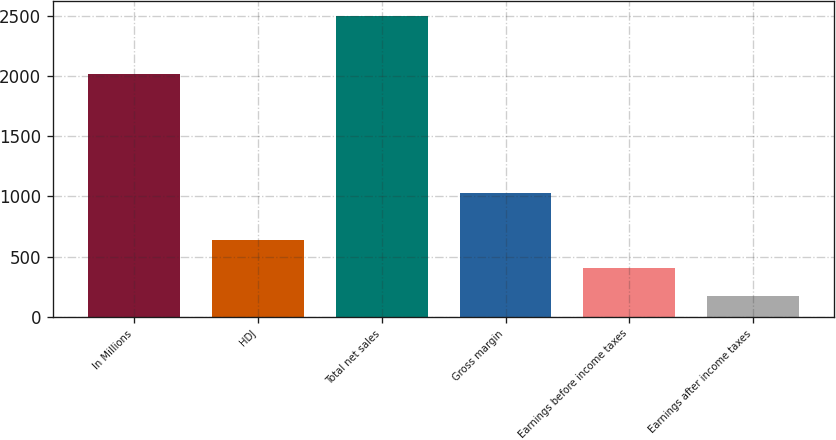Convert chart to OTSL. <chart><loc_0><loc_0><loc_500><loc_500><bar_chart><fcel>In Millions<fcel>HDJ<fcel>Total net sales<fcel>Gross margin<fcel>Earnings before income taxes<fcel>Earnings after income taxes<nl><fcel>2014<fcel>634<fcel>2494.8<fcel>1030.3<fcel>401.4<fcel>168.8<nl></chart> 